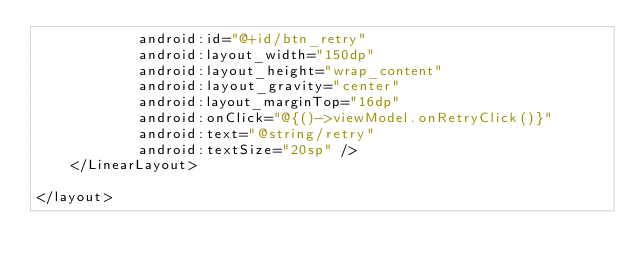Convert code to text. <code><loc_0><loc_0><loc_500><loc_500><_XML_>            android:id="@+id/btn_retry"
            android:layout_width="150dp"
            android:layout_height="wrap_content"
            android:layout_gravity="center"
            android:layout_marginTop="16dp"
            android:onClick="@{()->viewModel.onRetryClick()}"
            android:text="@string/retry"
            android:textSize="20sp" />
    </LinearLayout>

</layout></code> 